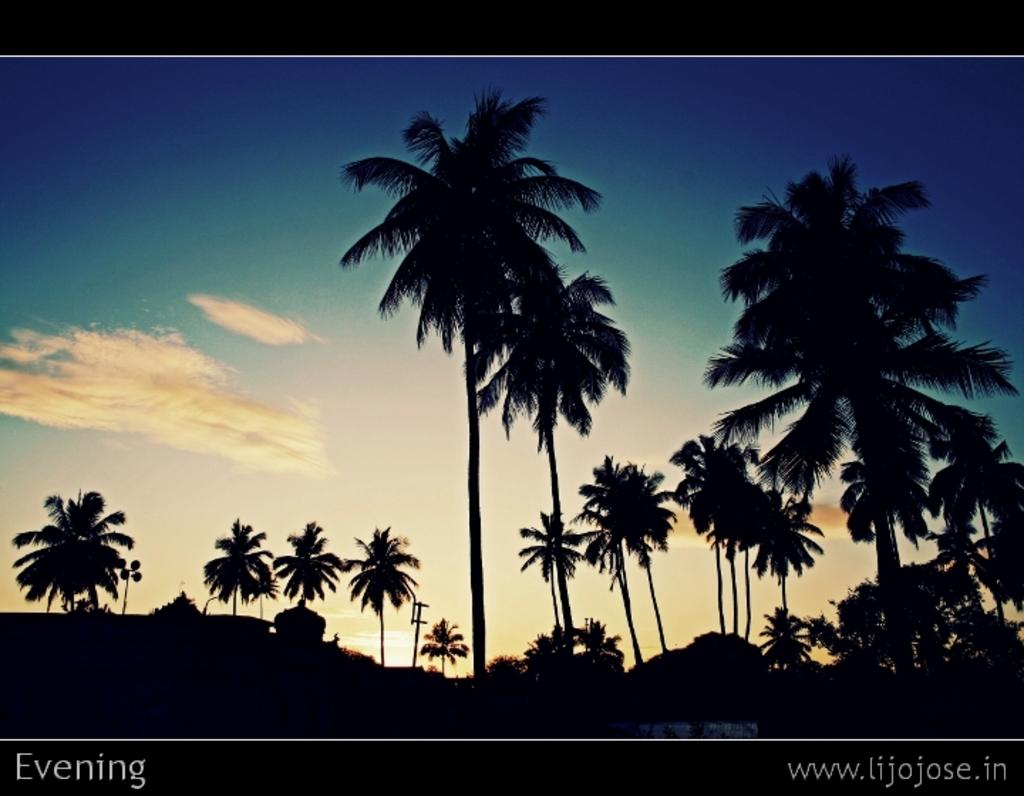How are the trees positioned in the image? The trees are far away from each other in the image. What color is the sky in the image? The sky is blue in the image. What can be seen in the distance in the image? There is a pole in the distance in the image. Where is the uncle washing his car in the image? There is no uncle or car washing activity present in the image. What type of mine can be seen in the image? There is no mine present in the image. 